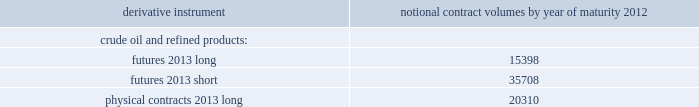Table of contents valero energy corporation and subsidiaries notes to consolidated financial statements ( continued ) commodity price risk we are exposed to market risks related to the volatility in the price of crude oil , refined products ( primarily gasoline and distillate ) , grain ( primarily corn ) , and natural gas used in our operations .
To reduce the impact of price volatility on our results of operations and cash flows , we use commodity derivative instruments , including futures , swaps , and options .
We use the futures markets for the available liquidity , which provides greater flexibility in transacting our hedging and trading operations .
We use swaps primarily to manage our price exposure .
Our positions in commodity derivative instruments are monitored and managed on a daily basis by a risk control group to ensure compliance with our stated risk management policy that has been approved by our board of directors .
For risk management purposes , we use fair value hedges , cash flow hedges , and economic hedges .
In addition to the use of derivative instruments to manage commodity price risk , we also enter into certain commodity derivative instruments for trading purposes .
Our objective for entering into each type of hedge or trading derivative is described below .
Fair value hedges fair value hedges are used to hedge price volatility in certain refining inventories and firm commitments to purchase inventories .
The level of activity for our fair value hedges is based on the level of our operating inventories , and generally represents the amount by which our inventories differ from our previous year-end lifo inventory levels .
As of december 31 , 2011 , we had the following outstanding commodity derivative instruments that were entered into to hedge crude oil and refined product inventories and commodity derivative instruments related to the physical purchase of crude oil and refined products at a fixed price .
The information presents the notional volume of outstanding contracts by type of instrument and year of maturity ( volumes in thousands of barrels ) .
Notional contract volumes by year of maturity derivative instrument 2012 .

How much more futures are short than long , in percentage? 
Computations: (35708 / 15398)
Answer: 2.319. 